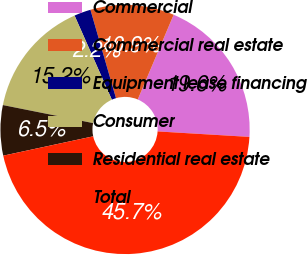<chart> <loc_0><loc_0><loc_500><loc_500><pie_chart><fcel>Commercial<fcel>Commercial real estate<fcel>Equipment lease financing<fcel>Consumer<fcel>Residential real estate<fcel>Total<nl><fcel>19.57%<fcel>10.86%<fcel>2.16%<fcel>15.22%<fcel>6.51%<fcel>45.68%<nl></chart> 